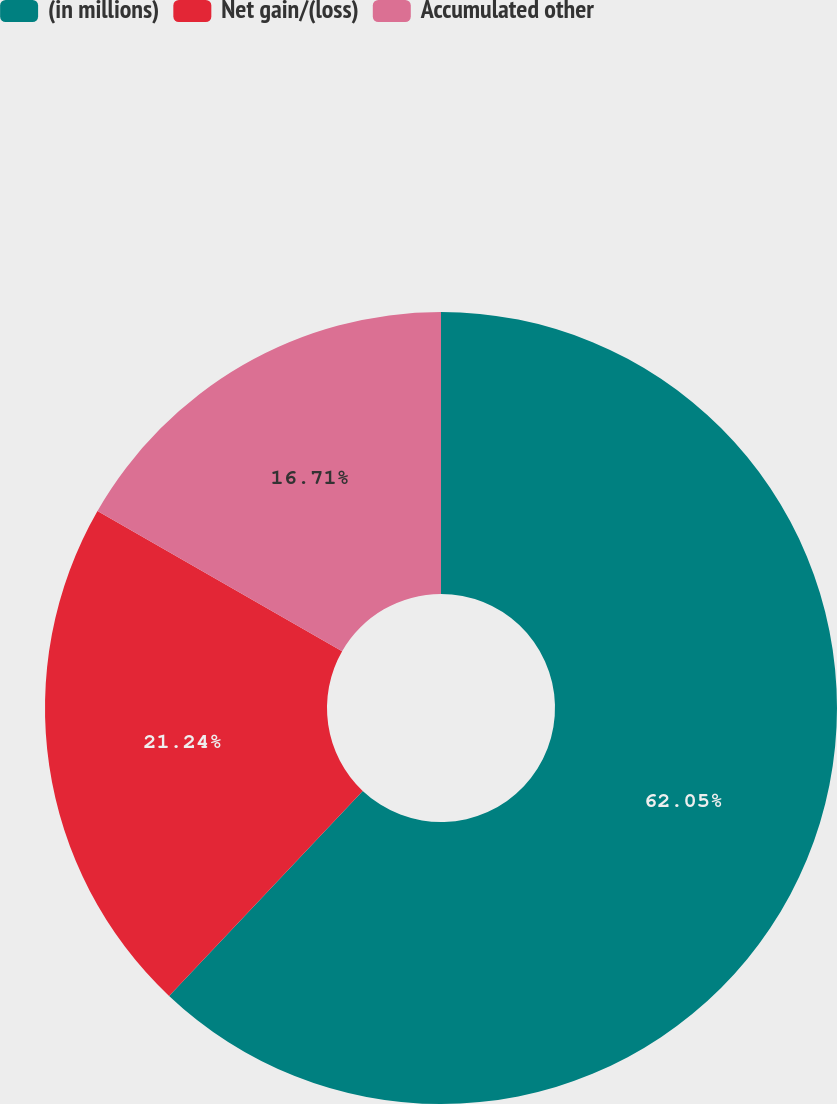Convert chart. <chart><loc_0><loc_0><loc_500><loc_500><pie_chart><fcel>(in millions)<fcel>Net gain/(loss)<fcel>Accumulated other<nl><fcel>62.04%<fcel>21.24%<fcel>16.71%<nl></chart> 